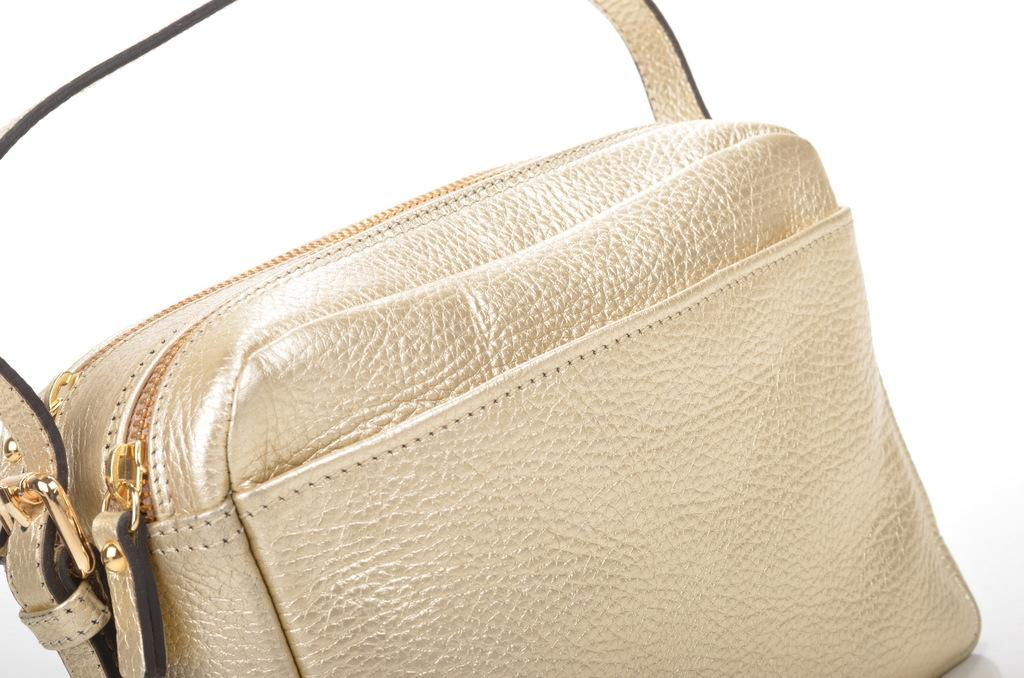What color is the handbag in the image? The handbag in the image is golden in color. What feature does the handbag have for opening and closing? The handbag has two zips for opening and closing. What additional design element can be seen on the handbag? The handbag has a strip. How many feathers are attached to the handbag in the image? There are no feathers attached to the handbag in the image. What type of ice can be seen melting on the handbag? There is no ice present in the image, so it cannot be melting on the handbag. 